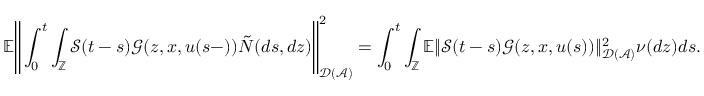<formula> <loc_0><loc_0><loc_500><loc_500>\mathbb { E } \left \| \int _ { 0 } ^ { t } \int _ { \mathbb { Z } } \mathcal { S } ( t - s ) \mathcal { G } ( z , x , u ( s - ) ) \tilde { N } ( d s , d z ) \right \| _ { \mathcal { D } ( \mathcal { A } ) } ^ { 2 } = \int _ { 0 } ^ { t } \int _ { \mathbb { Z } } \mathbb { E } \| \mathcal { S } ( t - s ) \mathcal { G } ( z , x , u ( s ) ) \| _ { \mathcal { D } ( \mathcal { A } ) } ^ { 2 } \nu ( d z ) d s .</formula> 